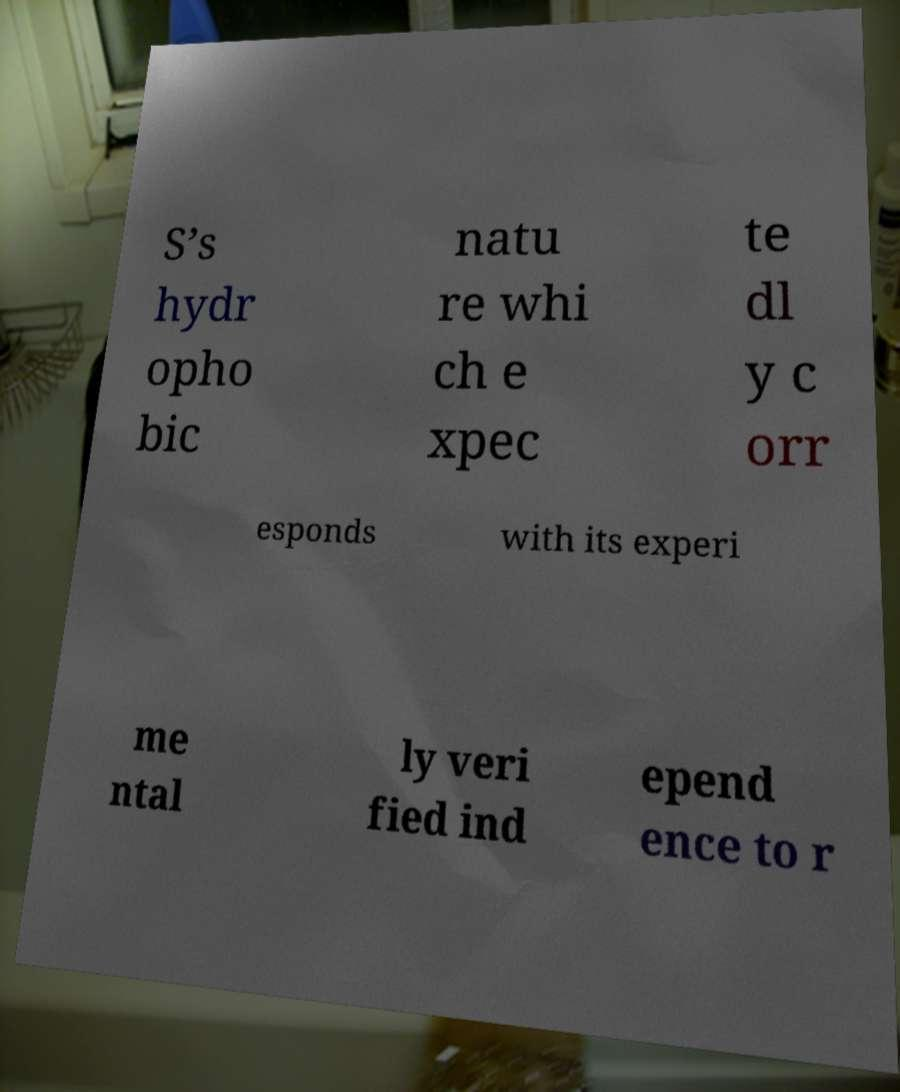Please read and relay the text visible in this image. What does it say? S’s hydr opho bic natu re whi ch e xpec te dl y c orr esponds with its experi me ntal ly veri fied ind epend ence to r 